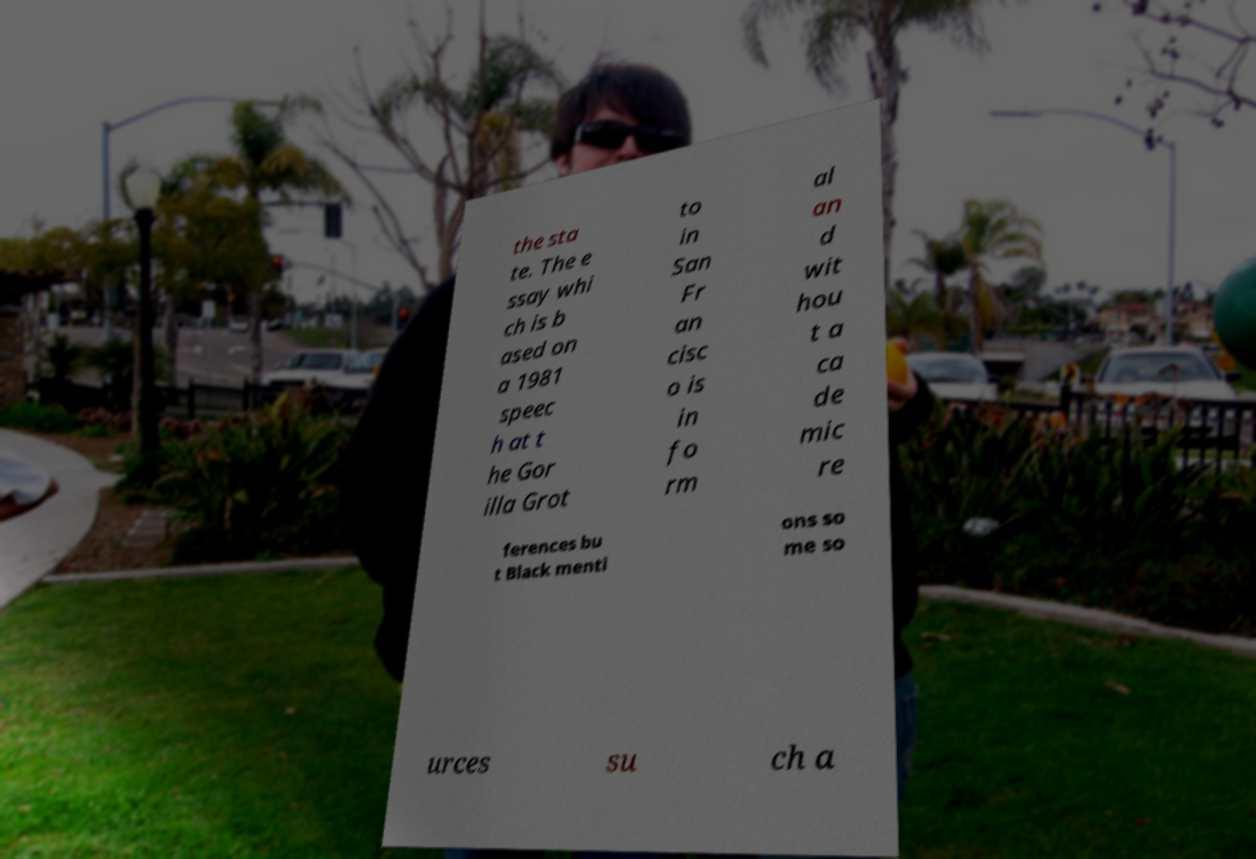What messages or text are displayed in this image? I need them in a readable, typed format. the sta te. The e ssay whi ch is b ased on a 1981 speec h at t he Gor illa Grot to in San Fr an cisc o is in fo rm al an d wit hou t a ca de mic re ferences bu t Black menti ons so me so urces su ch a 